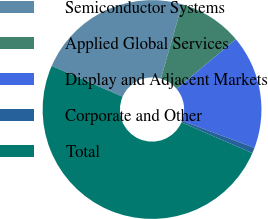Convert chart. <chart><loc_0><loc_0><loc_500><loc_500><pie_chart><fcel>Semiconductor Systems<fcel>Applied Global Services<fcel>Display and Adjacent Markets<fcel>Corporate and Other<fcel>Total<nl><fcel>22.91%<fcel>9.46%<fcel>16.81%<fcel>0.82%<fcel>50.0%<nl></chart> 